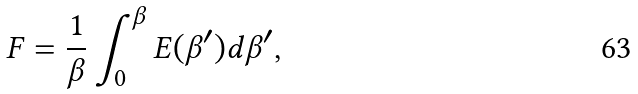<formula> <loc_0><loc_0><loc_500><loc_500>F = \frac { 1 } { \beta } \int _ { 0 } ^ { \beta } E ( \beta ^ { \prime } ) d \beta ^ { \prime } ,</formula> 